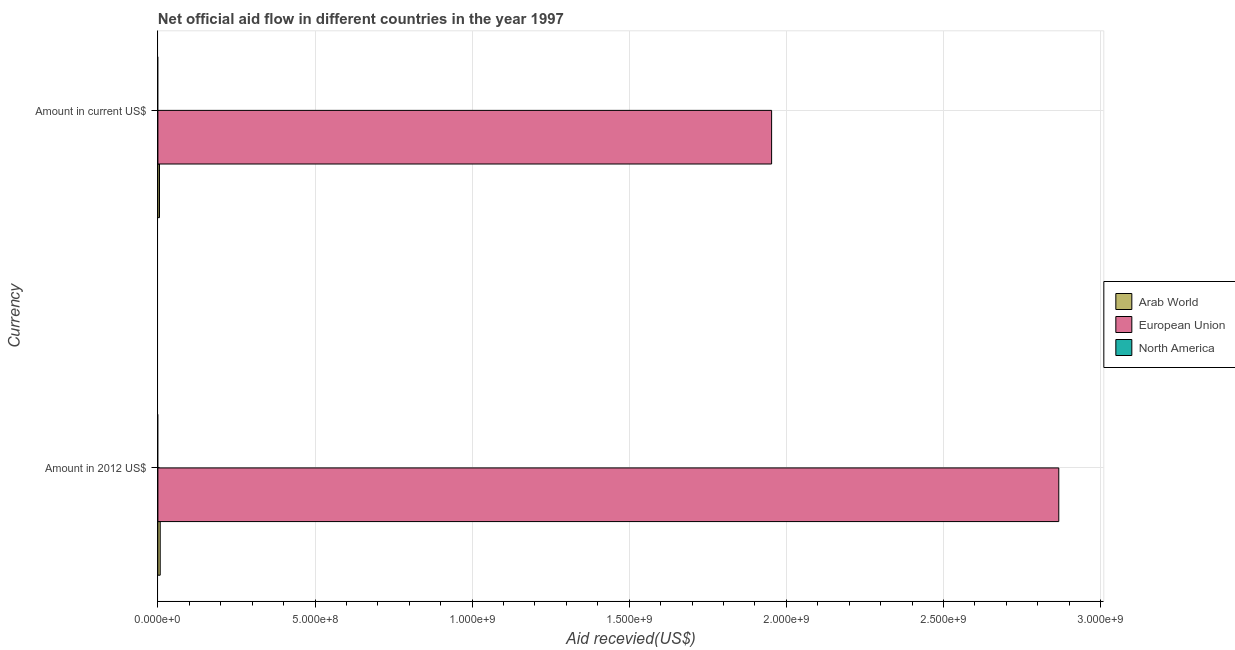How many groups of bars are there?
Ensure brevity in your answer.  2. How many bars are there on the 2nd tick from the top?
Ensure brevity in your answer.  2. How many bars are there on the 1st tick from the bottom?
Offer a terse response. 2. What is the label of the 1st group of bars from the top?
Offer a very short reply. Amount in current US$. What is the amount of aid received(expressed in us$) in European Union?
Your answer should be compact. 1.95e+09. Across all countries, what is the maximum amount of aid received(expressed in us$)?
Provide a succinct answer. 1.95e+09. Across all countries, what is the minimum amount of aid received(expressed in us$)?
Offer a very short reply. 0. In which country was the amount of aid received(expressed in us$) maximum?
Your answer should be very brief. European Union. What is the total amount of aid received(expressed in 2012 us$) in the graph?
Your answer should be very brief. 2.87e+09. What is the difference between the amount of aid received(expressed in us$) in Arab World and that in European Union?
Your answer should be compact. -1.95e+09. What is the difference between the amount of aid received(expressed in us$) in European Union and the amount of aid received(expressed in 2012 us$) in Arab World?
Make the answer very short. 1.95e+09. What is the average amount of aid received(expressed in 2012 us$) per country?
Offer a terse response. 9.58e+08. What is the difference between the amount of aid received(expressed in us$) and amount of aid received(expressed in 2012 us$) in European Union?
Provide a short and direct response. -9.14e+08. In how many countries, is the amount of aid received(expressed in us$) greater than 2900000000 US$?
Keep it short and to the point. 0. What is the ratio of the amount of aid received(expressed in 2012 us$) in Arab World to that in European Union?
Make the answer very short. 0. In how many countries, is the amount of aid received(expressed in 2012 us$) greater than the average amount of aid received(expressed in 2012 us$) taken over all countries?
Your answer should be compact. 1. How many bars are there?
Offer a terse response. 4. Are all the bars in the graph horizontal?
Keep it short and to the point. Yes. What is the difference between two consecutive major ticks on the X-axis?
Make the answer very short. 5.00e+08. Does the graph contain any zero values?
Keep it short and to the point. Yes. Does the graph contain grids?
Your answer should be compact. Yes. Where does the legend appear in the graph?
Offer a terse response. Center right. How are the legend labels stacked?
Provide a succinct answer. Vertical. What is the title of the graph?
Provide a short and direct response. Net official aid flow in different countries in the year 1997. Does "Marshall Islands" appear as one of the legend labels in the graph?
Your response must be concise. No. What is the label or title of the X-axis?
Keep it short and to the point. Aid recevied(US$). What is the label or title of the Y-axis?
Make the answer very short. Currency. What is the Aid recevied(US$) of Arab World in Amount in 2012 US$?
Keep it short and to the point. 7.29e+06. What is the Aid recevied(US$) of European Union in Amount in 2012 US$?
Ensure brevity in your answer.  2.87e+09. What is the Aid recevied(US$) in North America in Amount in 2012 US$?
Offer a very short reply. 0. What is the Aid recevied(US$) in Arab World in Amount in current US$?
Your response must be concise. 5.08e+06. What is the Aid recevied(US$) of European Union in Amount in current US$?
Keep it short and to the point. 1.95e+09. Across all Currency, what is the maximum Aid recevied(US$) of Arab World?
Your response must be concise. 7.29e+06. Across all Currency, what is the maximum Aid recevied(US$) in European Union?
Your answer should be very brief. 2.87e+09. Across all Currency, what is the minimum Aid recevied(US$) of Arab World?
Your response must be concise. 5.08e+06. Across all Currency, what is the minimum Aid recevied(US$) of European Union?
Make the answer very short. 1.95e+09. What is the total Aid recevied(US$) in Arab World in the graph?
Your answer should be compact. 1.24e+07. What is the total Aid recevied(US$) in European Union in the graph?
Offer a very short reply. 4.82e+09. What is the total Aid recevied(US$) of North America in the graph?
Make the answer very short. 0. What is the difference between the Aid recevied(US$) of Arab World in Amount in 2012 US$ and that in Amount in current US$?
Keep it short and to the point. 2.21e+06. What is the difference between the Aid recevied(US$) of European Union in Amount in 2012 US$ and that in Amount in current US$?
Keep it short and to the point. 9.14e+08. What is the difference between the Aid recevied(US$) in Arab World in Amount in 2012 US$ and the Aid recevied(US$) in European Union in Amount in current US$?
Provide a short and direct response. -1.95e+09. What is the average Aid recevied(US$) in Arab World per Currency?
Your response must be concise. 6.18e+06. What is the average Aid recevied(US$) in European Union per Currency?
Make the answer very short. 2.41e+09. What is the average Aid recevied(US$) in North America per Currency?
Your answer should be compact. 0. What is the difference between the Aid recevied(US$) of Arab World and Aid recevied(US$) of European Union in Amount in 2012 US$?
Offer a very short reply. -2.86e+09. What is the difference between the Aid recevied(US$) in Arab World and Aid recevied(US$) in European Union in Amount in current US$?
Your answer should be very brief. -1.95e+09. What is the ratio of the Aid recevied(US$) in Arab World in Amount in 2012 US$ to that in Amount in current US$?
Give a very brief answer. 1.44. What is the ratio of the Aid recevied(US$) in European Union in Amount in 2012 US$ to that in Amount in current US$?
Offer a terse response. 1.47. What is the difference between the highest and the second highest Aid recevied(US$) in Arab World?
Give a very brief answer. 2.21e+06. What is the difference between the highest and the second highest Aid recevied(US$) of European Union?
Give a very brief answer. 9.14e+08. What is the difference between the highest and the lowest Aid recevied(US$) in Arab World?
Ensure brevity in your answer.  2.21e+06. What is the difference between the highest and the lowest Aid recevied(US$) in European Union?
Offer a terse response. 9.14e+08. 